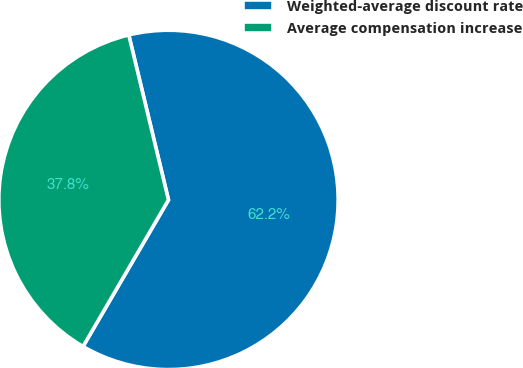<chart> <loc_0><loc_0><loc_500><loc_500><pie_chart><fcel>Weighted-average discount rate<fcel>Average compensation increase<nl><fcel>62.16%<fcel>37.84%<nl></chart> 